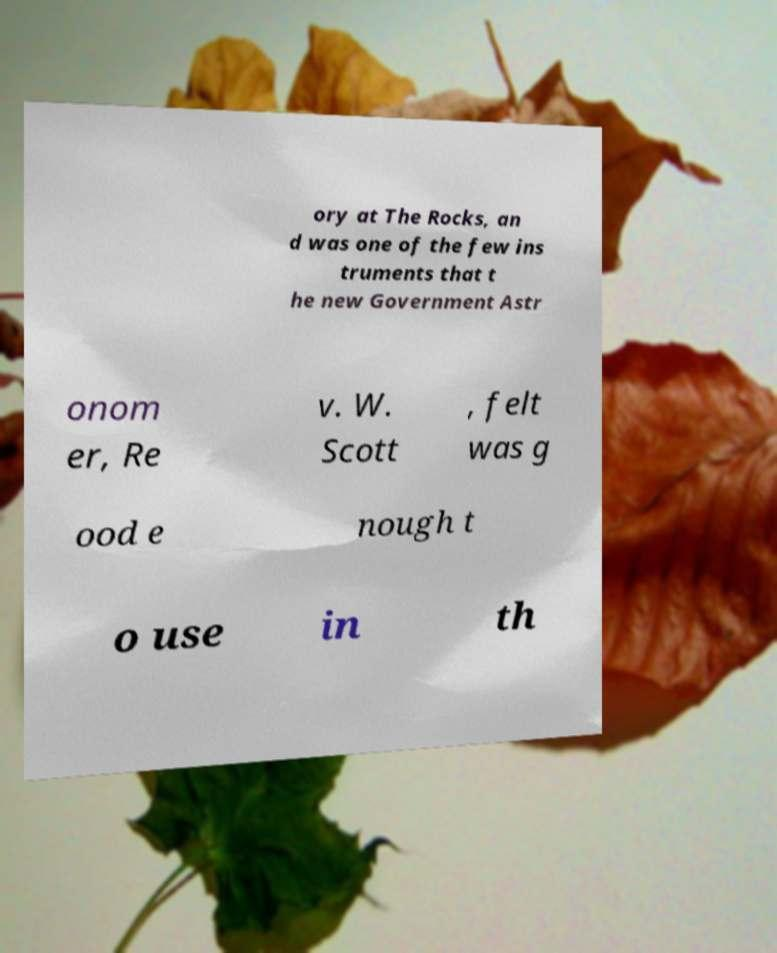There's text embedded in this image that I need extracted. Can you transcribe it verbatim? ory at The Rocks, an d was one of the few ins truments that t he new Government Astr onom er, Re v. W. Scott , felt was g ood e nough t o use in th 